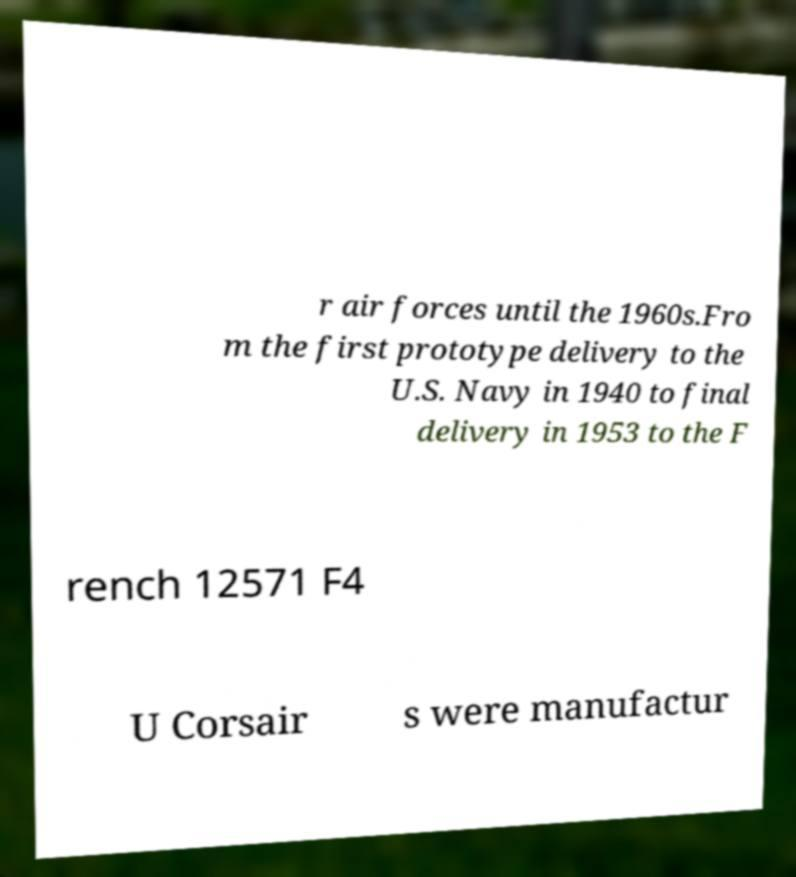Can you read and provide the text displayed in the image?This photo seems to have some interesting text. Can you extract and type it out for me? r air forces until the 1960s.Fro m the first prototype delivery to the U.S. Navy in 1940 to final delivery in 1953 to the F rench 12571 F4 U Corsair s were manufactur 